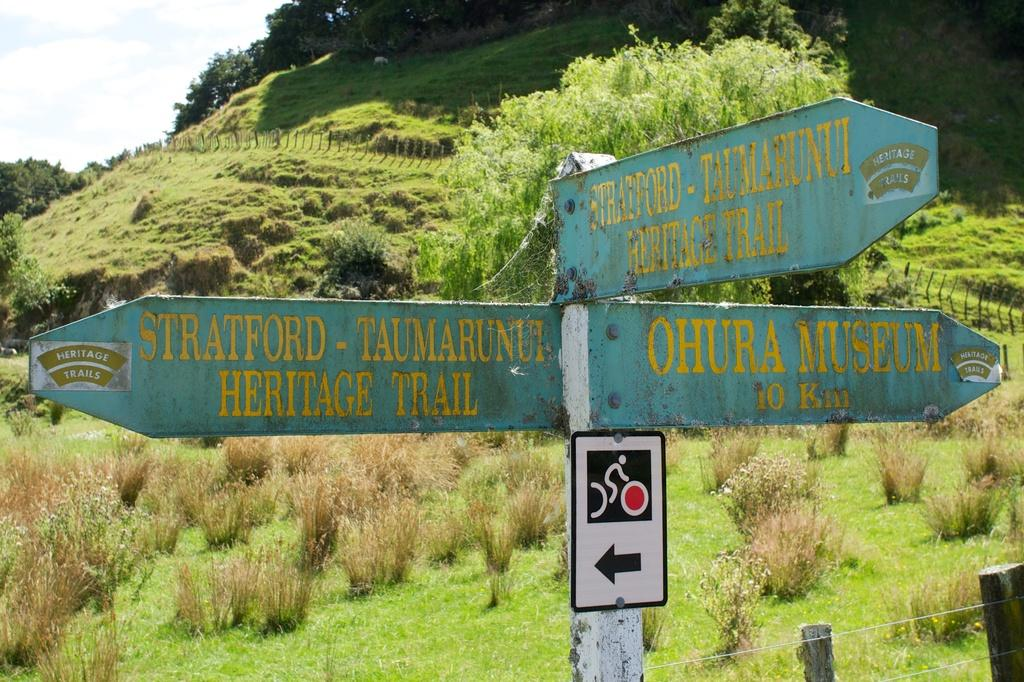<image>
Present a compact description of the photo's key features. A road sign says that Stratford is to the left and a museum is to the right. 